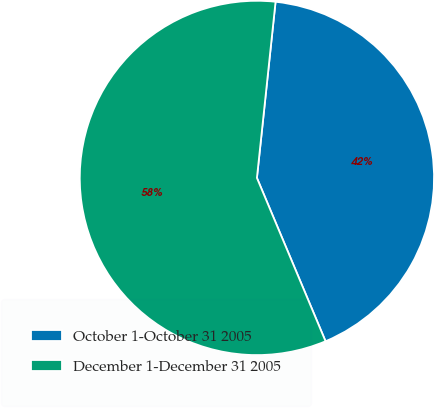Convert chart. <chart><loc_0><loc_0><loc_500><loc_500><pie_chart><fcel>October 1-October 31 2005<fcel>December 1-December 31 2005<nl><fcel>41.99%<fcel>58.01%<nl></chart> 